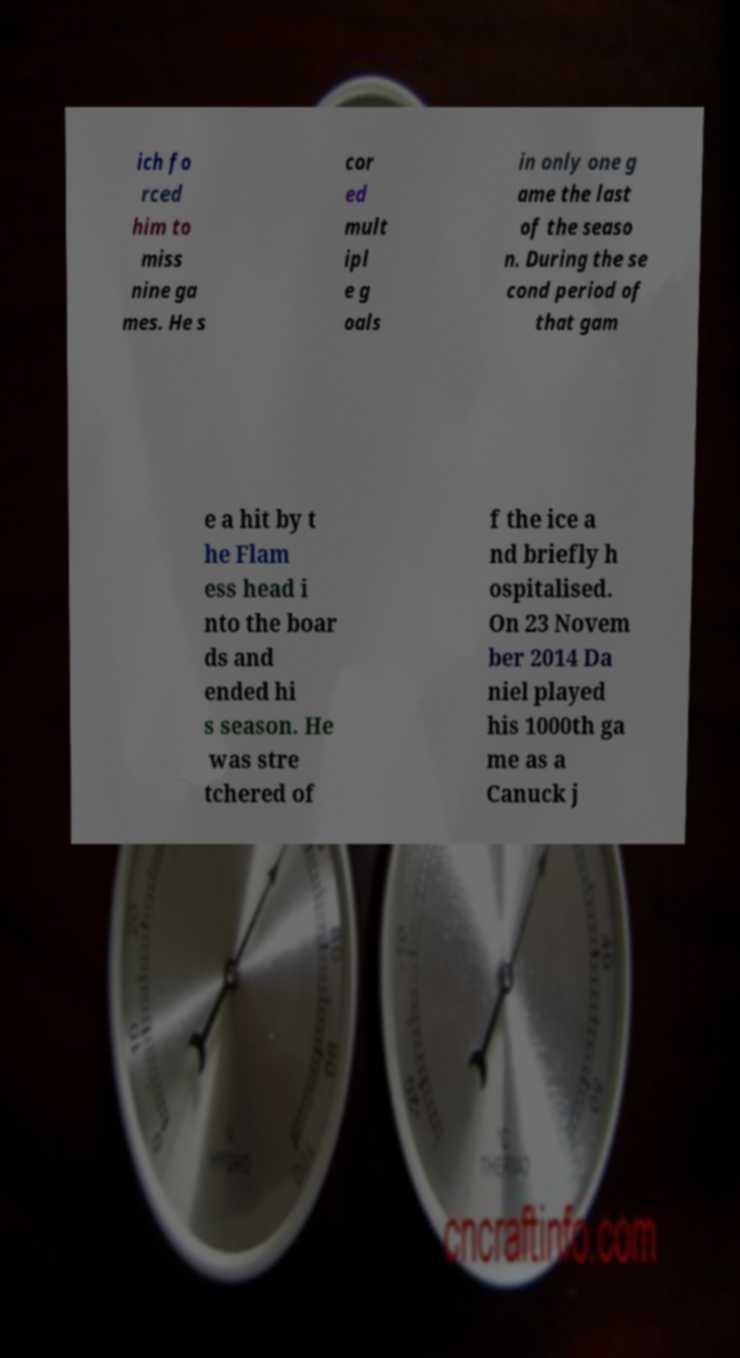Could you assist in decoding the text presented in this image and type it out clearly? ich fo rced him to miss nine ga mes. He s cor ed mult ipl e g oals in only one g ame the last of the seaso n. During the se cond period of that gam e a hit by t he Flam ess head i nto the boar ds and ended hi s season. He was stre tchered of f the ice a nd briefly h ospitalised. On 23 Novem ber 2014 Da niel played his 1000th ga me as a Canuck j 